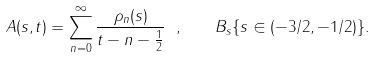<formula> <loc_0><loc_0><loc_500><loc_500>A ( s , t ) = \sum _ { n = 0 } ^ { \infty } \frac { \rho _ { n } ( s ) } { t - n - \frac { 1 } { 2 } } \ , \quad B _ { s } \{ s \in ( - 3 / 2 , - 1 / 2 ) \} .</formula> 